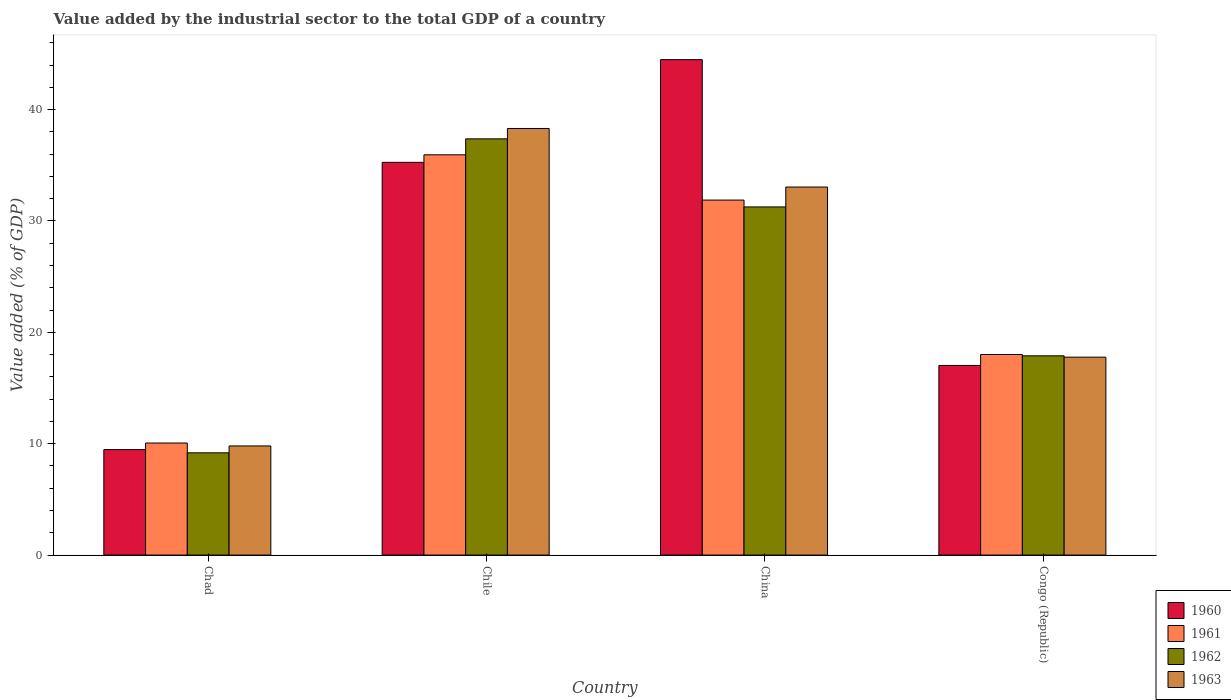How many different coloured bars are there?
Make the answer very short. 4. Are the number of bars per tick equal to the number of legend labels?
Your answer should be compact. Yes. What is the label of the 4th group of bars from the left?
Your answer should be compact. Congo (Republic). What is the value added by the industrial sector to the total GDP in 1960 in China?
Offer a very short reply. 44.49. Across all countries, what is the maximum value added by the industrial sector to the total GDP in 1963?
Your response must be concise. 38.31. Across all countries, what is the minimum value added by the industrial sector to the total GDP in 1960?
Offer a terse response. 9.47. In which country was the value added by the industrial sector to the total GDP in 1962 maximum?
Offer a terse response. Chile. In which country was the value added by the industrial sector to the total GDP in 1961 minimum?
Make the answer very short. Chad. What is the total value added by the industrial sector to the total GDP in 1962 in the graph?
Give a very brief answer. 95.71. What is the difference between the value added by the industrial sector to the total GDP in 1962 in Chad and that in Congo (Republic)?
Keep it short and to the point. -8.71. What is the difference between the value added by the industrial sector to the total GDP in 1960 in Chad and the value added by the industrial sector to the total GDP in 1962 in Congo (Republic)?
Your answer should be compact. -8.42. What is the average value added by the industrial sector to the total GDP in 1960 per country?
Offer a terse response. 26.56. What is the difference between the value added by the industrial sector to the total GDP of/in 1961 and value added by the industrial sector to the total GDP of/in 1960 in Chad?
Keep it short and to the point. 0.59. In how many countries, is the value added by the industrial sector to the total GDP in 1963 greater than 2 %?
Your answer should be very brief. 4. What is the ratio of the value added by the industrial sector to the total GDP in 1961 in China to that in Congo (Republic)?
Your answer should be very brief. 1.77. Is the value added by the industrial sector to the total GDP in 1961 in Chad less than that in Chile?
Keep it short and to the point. Yes. What is the difference between the highest and the second highest value added by the industrial sector to the total GDP in 1961?
Keep it short and to the point. -17.93. What is the difference between the highest and the lowest value added by the industrial sector to the total GDP in 1963?
Provide a short and direct response. 28.51. In how many countries, is the value added by the industrial sector to the total GDP in 1962 greater than the average value added by the industrial sector to the total GDP in 1962 taken over all countries?
Make the answer very short. 2. Is the sum of the value added by the industrial sector to the total GDP in 1963 in Chile and China greater than the maximum value added by the industrial sector to the total GDP in 1961 across all countries?
Ensure brevity in your answer.  Yes. What does the 1st bar from the left in China represents?
Provide a succinct answer. 1960. Is it the case that in every country, the sum of the value added by the industrial sector to the total GDP in 1960 and value added by the industrial sector to the total GDP in 1961 is greater than the value added by the industrial sector to the total GDP in 1963?
Offer a very short reply. Yes. Are all the bars in the graph horizontal?
Make the answer very short. No. What is the difference between two consecutive major ticks on the Y-axis?
Offer a very short reply. 10. Does the graph contain grids?
Provide a short and direct response. No. How many legend labels are there?
Make the answer very short. 4. What is the title of the graph?
Give a very brief answer. Value added by the industrial sector to the total GDP of a country. What is the label or title of the X-axis?
Give a very brief answer. Country. What is the label or title of the Y-axis?
Ensure brevity in your answer.  Value added (% of GDP). What is the Value added (% of GDP) in 1960 in Chad?
Ensure brevity in your answer.  9.47. What is the Value added (% of GDP) in 1961 in Chad?
Keep it short and to the point. 10.06. What is the Value added (% of GDP) of 1962 in Chad?
Give a very brief answer. 9.18. What is the Value added (% of GDP) in 1963 in Chad?
Keep it short and to the point. 9.8. What is the Value added (% of GDP) in 1960 in Chile?
Offer a terse response. 35.27. What is the Value added (% of GDP) in 1961 in Chile?
Offer a very short reply. 35.94. What is the Value added (% of GDP) in 1962 in Chile?
Offer a very short reply. 37.38. What is the Value added (% of GDP) of 1963 in Chile?
Your response must be concise. 38.31. What is the Value added (% of GDP) in 1960 in China?
Provide a succinct answer. 44.49. What is the Value added (% of GDP) of 1961 in China?
Your answer should be compact. 31.88. What is the Value added (% of GDP) of 1962 in China?
Make the answer very short. 31.26. What is the Value added (% of GDP) in 1963 in China?
Provide a succinct answer. 33.05. What is the Value added (% of GDP) of 1960 in Congo (Republic)?
Your answer should be very brief. 17.03. What is the Value added (% of GDP) in 1961 in Congo (Republic)?
Make the answer very short. 18.01. What is the Value added (% of GDP) of 1962 in Congo (Republic)?
Provide a short and direct response. 17.89. What is the Value added (% of GDP) of 1963 in Congo (Republic)?
Make the answer very short. 17.77. Across all countries, what is the maximum Value added (% of GDP) of 1960?
Provide a succinct answer. 44.49. Across all countries, what is the maximum Value added (% of GDP) of 1961?
Offer a terse response. 35.94. Across all countries, what is the maximum Value added (% of GDP) in 1962?
Offer a very short reply. 37.38. Across all countries, what is the maximum Value added (% of GDP) in 1963?
Keep it short and to the point. 38.31. Across all countries, what is the minimum Value added (% of GDP) in 1960?
Provide a short and direct response. 9.47. Across all countries, what is the minimum Value added (% of GDP) in 1961?
Provide a succinct answer. 10.06. Across all countries, what is the minimum Value added (% of GDP) of 1962?
Keep it short and to the point. 9.18. Across all countries, what is the minimum Value added (% of GDP) in 1963?
Give a very brief answer. 9.8. What is the total Value added (% of GDP) of 1960 in the graph?
Ensure brevity in your answer.  106.26. What is the total Value added (% of GDP) in 1961 in the graph?
Your answer should be very brief. 95.89. What is the total Value added (% of GDP) of 1962 in the graph?
Provide a succinct answer. 95.71. What is the total Value added (% of GDP) in 1963 in the graph?
Keep it short and to the point. 98.93. What is the difference between the Value added (% of GDP) of 1960 in Chad and that in Chile?
Provide a succinct answer. -25.79. What is the difference between the Value added (% of GDP) of 1961 in Chad and that in Chile?
Keep it short and to the point. -25.88. What is the difference between the Value added (% of GDP) of 1962 in Chad and that in Chile?
Provide a succinct answer. -28.19. What is the difference between the Value added (% of GDP) of 1963 in Chad and that in Chile?
Your answer should be compact. -28.51. What is the difference between the Value added (% of GDP) in 1960 in Chad and that in China?
Your response must be concise. -35.01. What is the difference between the Value added (% of GDP) in 1961 in Chad and that in China?
Make the answer very short. -21.81. What is the difference between the Value added (% of GDP) in 1962 in Chad and that in China?
Give a very brief answer. -22.08. What is the difference between the Value added (% of GDP) in 1963 in Chad and that in China?
Your answer should be compact. -23.25. What is the difference between the Value added (% of GDP) in 1960 in Chad and that in Congo (Republic)?
Keep it short and to the point. -7.55. What is the difference between the Value added (% of GDP) of 1961 in Chad and that in Congo (Republic)?
Make the answer very short. -7.95. What is the difference between the Value added (% of GDP) of 1962 in Chad and that in Congo (Republic)?
Make the answer very short. -8.71. What is the difference between the Value added (% of GDP) of 1963 in Chad and that in Congo (Republic)?
Your answer should be very brief. -7.97. What is the difference between the Value added (% of GDP) in 1960 in Chile and that in China?
Provide a short and direct response. -9.22. What is the difference between the Value added (% of GDP) of 1961 in Chile and that in China?
Your answer should be compact. 4.07. What is the difference between the Value added (% of GDP) of 1962 in Chile and that in China?
Give a very brief answer. 6.11. What is the difference between the Value added (% of GDP) in 1963 in Chile and that in China?
Ensure brevity in your answer.  5.26. What is the difference between the Value added (% of GDP) in 1960 in Chile and that in Congo (Republic)?
Your answer should be compact. 18.24. What is the difference between the Value added (% of GDP) in 1961 in Chile and that in Congo (Republic)?
Keep it short and to the point. 17.93. What is the difference between the Value added (% of GDP) of 1962 in Chile and that in Congo (Republic)?
Provide a short and direct response. 19.48. What is the difference between the Value added (% of GDP) of 1963 in Chile and that in Congo (Republic)?
Keep it short and to the point. 20.54. What is the difference between the Value added (% of GDP) in 1960 in China and that in Congo (Republic)?
Make the answer very short. 27.46. What is the difference between the Value added (% of GDP) of 1961 in China and that in Congo (Republic)?
Provide a succinct answer. 13.87. What is the difference between the Value added (% of GDP) of 1962 in China and that in Congo (Republic)?
Provide a succinct answer. 13.37. What is the difference between the Value added (% of GDP) of 1963 in China and that in Congo (Republic)?
Give a very brief answer. 15.28. What is the difference between the Value added (% of GDP) in 1960 in Chad and the Value added (% of GDP) in 1961 in Chile?
Provide a succinct answer. -26.47. What is the difference between the Value added (% of GDP) of 1960 in Chad and the Value added (% of GDP) of 1962 in Chile?
Provide a succinct answer. -27.9. What is the difference between the Value added (% of GDP) in 1960 in Chad and the Value added (% of GDP) in 1963 in Chile?
Your response must be concise. -28.83. What is the difference between the Value added (% of GDP) of 1961 in Chad and the Value added (% of GDP) of 1962 in Chile?
Your answer should be very brief. -27.31. What is the difference between the Value added (% of GDP) of 1961 in Chad and the Value added (% of GDP) of 1963 in Chile?
Your answer should be compact. -28.25. What is the difference between the Value added (% of GDP) in 1962 in Chad and the Value added (% of GDP) in 1963 in Chile?
Give a very brief answer. -29.13. What is the difference between the Value added (% of GDP) of 1960 in Chad and the Value added (% of GDP) of 1961 in China?
Provide a succinct answer. -22.4. What is the difference between the Value added (% of GDP) of 1960 in Chad and the Value added (% of GDP) of 1962 in China?
Your response must be concise. -21.79. What is the difference between the Value added (% of GDP) in 1960 in Chad and the Value added (% of GDP) in 1963 in China?
Your answer should be very brief. -23.58. What is the difference between the Value added (% of GDP) in 1961 in Chad and the Value added (% of GDP) in 1962 in China?
Offer a terse response. -21.2. What is the difference between the Value added (% of GDP) of 1961 in Chad and the Value added (% of GDP) of 1963 in China?
Your response must be concise. -22.99. What is the difference between the Value added (% of GDP) of 1962 in Chad and the Value added (% of GDP) of 1963 in China?
Ensure brevity in your answer.  -23.87. What is the difference between the Value added (% of GDP) of 1960 in Chad and the Value added (% of GDP) of 1961 in Congo (Republic)?
Your answer should be very brief. -8.54. What is the difference between the Value added (% of GDP) of 1960 in Chad and the Value added (% of GDP) of 1962 in Congo (Republic)?
Make the answer very short. -8.42. What is the difference between the Value added (% of GDP) in 1960 in Chad and the Value added (% of GDP) in 1963 in Congo (Republic)?
Make the answer very short. -8.3. What is the difference between the Value added (% of GDP) in 1961 in Chad and the Value added (% of GDP) in 1962 in Congo (Republic)?
Make the answer very short. -7.83. What is the difference between the Value added (% of GDP) in 1961 in Chad and the Value added (% of GDP) in 1963 in Congo (Republic)?
Give a very brief answer. -7.71. What is the difference between the Value added (% of GDP) of 1962 in Chad and the Value added (% of GDP) of 1963 in Congo (Republic)?
Provide a short and direct response. -8.59. What is the difference between the Value added (% of GDP) of 1960 in Chile and the Value added (% of GDP) of 1961 in China?
Your answer should be very brief. 3.39. What is the difference between the Value added (% of GDP) in 1960 in Chile and the Value added (% of GDP) in 1962 in China?
Provide a succinct answer. 4. What is the difference between the Value added (% of GDP) of 1960 in Chile and the Value added (% of GDP) of 1963 in China?
Ensure brevity in your answer.  2.22. What is the difference between the Value added (% of GDP) of 1961 in Chile and the Value added (% of GDP) of 1962 in China?
Your answer should be very brief. 4.68. What is the difference between the Value added (% of GDP) in 1961 in Chile and the Value added (% of GDP) in 1963 in China?
Provide a short and direct response. 2.89. What is the difference between the Value added (% of GDP) in 1962 in Chile and the Value added (% of GDP) in 1963 in China?
Provide a short and direct response. 4.33. What is the difference between the Value added (% of GDP) in 1960 in Chile and the Value added (% of GDP) in 1961 in Congo (Republic)?
Offer a very short reply. 17.26. What is the difference between the Value added (% of GDP) in 1960 in Chile and the Value added (% of GDP) in 1962 in Congo (Republic)?
Offer a terse response. 17.37. What is the difference between the Value added (% of GDP) in 1960 in Chile and the Value added (% of GDP) in 1963 in Congo (Republic)?
Ensure brevity in your answer.  17.49. What is the difference between the Value added (% of GDP) of 1961 in Chile and the Value added (% of GDP) of 1962 in Congo (Republic)?
Your answer should be compact. 18.05. What is the difference between the Value added (% of GDP) in 1961 in Chile and the Value added (% of GDP) in 1963 in Congo (Republic)?
Keep it short and to the point. 18.17. What is the difference between the Value added (% of GDP) in 1962 in Chile and the Value added (% of GDP) in 1963 in Congo (Republic)?
Your answer should be very brief. 19.6. What is the difference between the Value added (% of GDP) of 1960 in China and the Value added (% of GDP) of 1961 in Congo (Republic)?
Your answer should be compact. 26.48. What is the difference between the Value added (% of GDP) of 1960 in China and the Value added (% of GDP) of 1962 in Congo (Republic)?
Offer a terse response. 26.6. What is the difference between the Value added (% of GDP) of 1960 in China and the Value added (% of GDP) of 1963 in Congo (Republic)?
Keep it short and to the point. 26.72. What is the difference between the Value added (% of GDP) in 1961 in China and the Value added (% of GDP) in 1962 in Congo (Republic)?
Offer a very short reply. 13.98. What is the difference between the Value added (% of GDP) of 1961 in China and the Value added (% of GDP) of 1963 in Congo (Republic)?
Your answer should be very brief. 14.1. What is the difference between the Value added (% of GDP) of 1962 in China and the Value added (% of GDP) of 1963 in Congo (Republic)?
Keep it short and to the point. 13.49. What is the average Value added (% of GDP) of 1960 per country?
Offer a terse response. 26.56. What is the average Value added (% of GDP) in 1961 per country?
Offer a terse response. 23.97. What is the average Value added (% of GDP) in 1962 per country?
Offer a very short reply. 23.93. What is the average Value added (% of GDP) in 1963 per country?
Your response must be concise. 24.73. What is the difference between the Value added (% of GDP) in 1960 and Value added (% of GDP) in 1961 in Chad?
Your answer should be very brief. -0.59. What is the difference between the Value added (% of GDP) of 1960 and Value added (% of GDP) of 1962 in Chad?
Your response must be concise. 0.29. What is the difference between the Value added (% of GDP) of 1960 and Value added (% of GDP) of 1963 in Chad?
Offer a terse response. -0.32. What is the difference between the Value added (% of GDP) of 1961 and Value added (% of GDP) of 1962 in Chad?
Your answer should be compact. 0.88. What is the difference between the Value added (% of GDP) of 1961 and Value added (% of GDP) of 1963 in Chad?
Your response must be concise. 0.26. What is the difference between the Value added (% of GDP) of 1962 and Value added (% of GDP) of 1963 in Chad?
Your response must be concise. -0.62. What is the difference between the Value added (% of GDP) in 1960 and Value added (% of GDP) in 1961 in Chile?
Your answer should be compact. -0.68. What is the difference between the Value added (% of GDP) of 1960 and Value added (% of GDP) of 1962 in Chile?
Offer a very short reply. -2.11. What is the difference between the Value added (% of GDP) of 1960 and Value added (% of GDP) of 1963 in Chile?
Offer a very short reply. -3.04. What is the difference between the Value added (% of GDP) in 1961 and Value added (% of GDP) in 1962 in Chile?
Keep it short and to the point. -1.43. What is the difference between the Value added (% of GDP) of 1961 and Value added (% of GDP) of 1963 in Chile?
Give a very brief answer. -2.36. What is the difference between the Value added (% of GDP) in 1962 and Value added (% of GDP) in 1963 in Chile?
Your response must be concise. -0.93. What is the difference between the Value added (% of GDP) of 1960 and Value added (% of GDP) of 1961 in China?
Provide a short and direct response. 12.61. What is the difference between the Value added (% of GDP) in 1960 and Value added (% of GDP) in 1962 in China?
Make the answer very short. 13.23. What is the difference between the Value added (% of GDP) of 1960 and Value added (% of GDP) of 1963 in China?
Offer a terse response. 11.44. What is the difference between the Value added (% of GDP) of 1961 and Value added (% of GDP) of 1962 in China?
Your answer should be very brief. 0.61. What is the difference between the Value added (% of GDP) of 1961 and Value added (% of GDP) of 1963 in China?
Provide a succinct answer. -1.17. What is the difference between the Value added (% of GDP) of 1962 and Value added (% of GDP) of 1963 in China?
Provide a succinct answer. -1.79. What is the difference between the Value added (% of GDP) in 1960 and Value added (% of GDP) in 1961 in Congo (Republic)?
Provide a succinct answer. -0.98. What is the difference between the Value added (% of GDP) in 1960 and Value added (% of GDP) in 1962 in Congo (Republic)?
Your answer should be compact. -0.86. What is the difference between the Value added (% of GDP) in 1960 and Value added (% of GDP) in 1963 in Congo (Republic)?
Provide a short and direct response. -0.74. What is the difference between the Value added (% of GDP) in 1961 and Value added (% of GDP) in 1962 in Congo (Republic)?
Offer a very short reply. 0.12. What is the difference between the Value added (% of GDP) of 1961 and Value added (% of GDP) of 1963 in Congo (Republic)?
Your response must be concise. 0.24. What is the difference between the Value added (% of GDP) of 1962 and Value added (% of GDP) of 1963 in Congo (Republic)?
Your answer should be compact. 0.12. What is the ratio of the Value added (% of GDP) in 1960 in Chad to that in Chile?
Offer a terse response. 0.27. What is the ratio of the Value added (% of GDP) of 1961 in Chad to that in Chile?
Provide a short and direct response. 0.28. What is the ratio of the Value added (% of GDP) of 1962 in Chad to that in Chile?
Your answer should be very brief. 0.25. What is the ratio of the Value added (% of GDP) of 1963 in Chad to that in Chile?
Your response must be concise. 0.26. What is the ratio of the Value added (% of GDP) in 1960 in Chad to that in China?
Offer a very short reply. 0.21. What is the ratio of the Value added (% of GDP) in 1961 in Chad to that in China?
Provide a short and direct response. 0.32. What is the ratio of the Value added (% of GDP) of 1962 in Chad to that in China?
Provide a succinct answer. 0.29. What is the ratio of the Value added (% of GDP) in 1963 in Chad to that in China?
Give a very brief answer. 0.3. What is the ratio of the Value added (% of GDP) in 1960 in Chad to that in Congo (Republic)?
Your response must be concise. 0.56. What is the ratio of the Value added (% of GDP) in 1961 in Chad to that in Congo (Republic)?
Your response must be concise. 0.56. What is the ratio of the Value added (% of GDP) in 1962 in Chad to that in Congo (Republic)?
Your answer should be compact. 0.51. What is the ratio of the Value added (% of GDP) in 1963 in Chad to that in Congo (Republic)?
Your answer should be compact. 0.55. What is the ratio of the Value added (% of GDP) of 1960 in Chile to that in China?
Provide a short and direct response. 0.79. What is the ratio of the Value added (% of GDP) in 1961 in Chile to that in China?
Provide a short and direct response. 1.13. What is the ratio of the Value added (% of GDP) in 1962 in Chile to that in China?
Offer a very short reply. 1.2. What is the ratio of the Value added (% of GDP) in 1963 in Chile to that in China?
Make the answer very short. 1.16. What is the ratio of the Value added (% of GDP) of 1960 in Chile to that in Congo (Republic)?
Ensure brevity in your answer.  2.07. What is the ratio of the Value added (% of GDP) of 1961 in Chile to that in Congo (Republic)?
Provide a short and direct response. 2. What is the ratio of the Value added (% of GDP) in 1962 in Chile to that in Congo (Republic)?
Your answer should be compact. 2.09. What is the ratio of the Value added (% of GDP) in 1963 in Chile to that in Congo (Republic)?
Offer a very short reply. 2.16. What is the ratio of the Value added (% of GDP) in 1960 in China to that in Congo (Republic)?
Keep it short and to the point. 2.61. What is the ratio of the Value added (% of GDP) in 1961 in China to that in Congo (Republic)?
Offer a terse response. 1.77. What is the ratio of the Value added (% of GDP) in 1962 in China to that in Congo (Republic)?
Give a very brief answer. 1.75. What is the ratio of the Value added (% of GDP) of 1963 in China to that in Congo (Republic)?
Your answer should be very brief. 1.86. What is the difference between the highest and the second highest Value added (% of GDP) of 1960?
Keep it short and to the point. 9.22. What is the difference between the highest and the second highest Value added (% of GDP) in 1961?
Offer a very short reply. 4.07. What is the difference between the highest and the second highest Value added (% of GDP) in 1962?
Your answer should be compact. 6.11. What is the difference between the highest and the second highest Value added (% of GDP) in 1963?
Keep it short and to the point. 5.26. What is the difference between the highest and the lowest Value added (% of GDP) of 1960?
Give a very brief answer. 35.01. What is the difference between the highest and the lowest Value added (% of GDP) in 1961?
Provide a succinct answer. 25.88. What is the difference between the highest and the lowest Value added (% of GDP) in 1962?
Make the answer very short. 28.19. What is the difference between the highest and the lowest Value added (% of GDP) in 1963?
Ensure brevity in your answer.  28.51. 